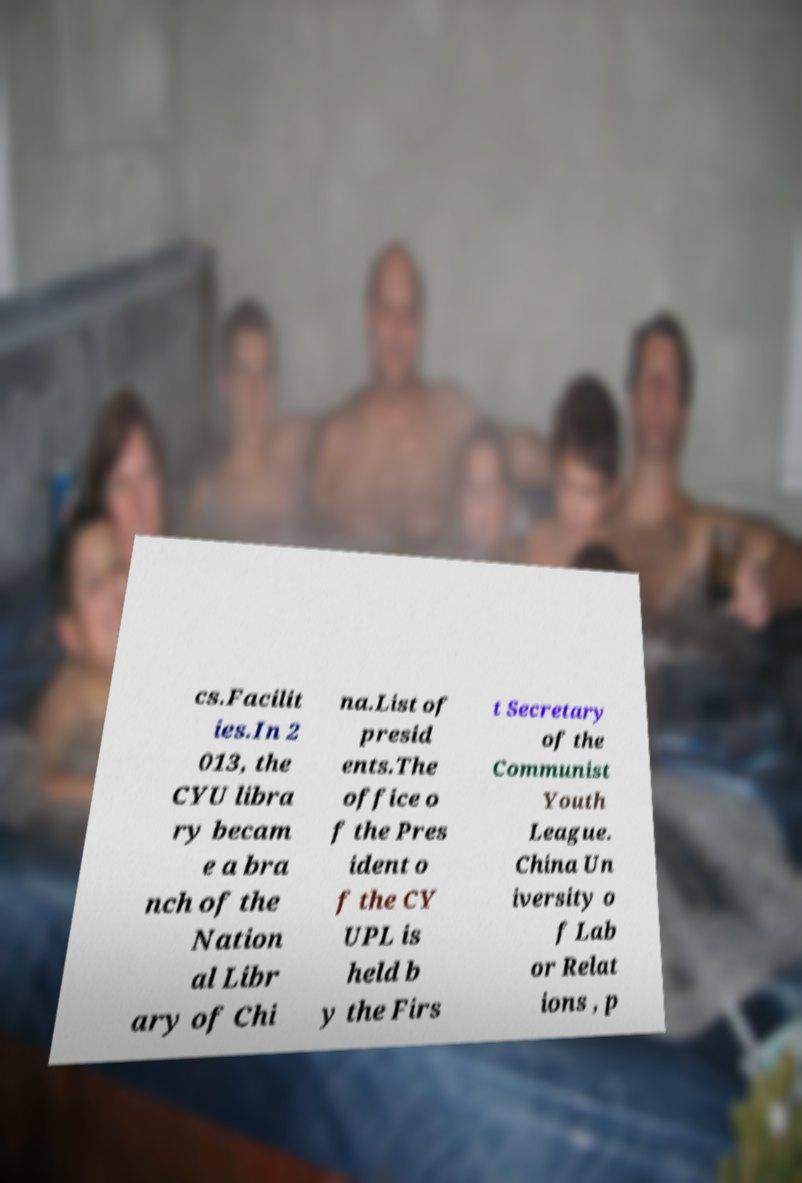Please identify and transcribe the text found in this image. cs.Facilit ies.In 2 013, the CYU libra ry becam e a bra nch of the Nation al Libr ary of Chi na.List of presid ents.The office o f the Pres ident o f the CY UPL is held b y the Firs t Secretary of the Communist Youth League. China Un iversity o f Lab or Relat ions , p 